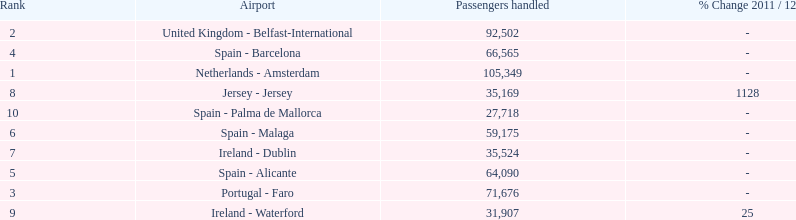How many passengers were handled in an airport in spain? 217,548. 